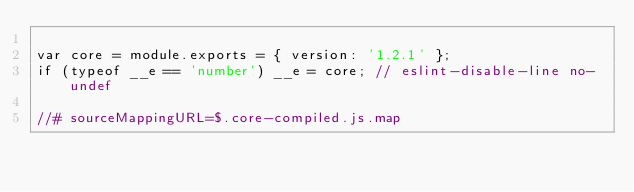Convert code to text. <code><loc_0><loc_0><loc_500><loc_500><_JavaScript_>
var core = module.exports = { version: '1.2.1' };
if (typeof __e == 'number') __e = core; // eslint-disable-line no-undef

//# sourceMappingURL=$.core-compiled.js.map</code> 